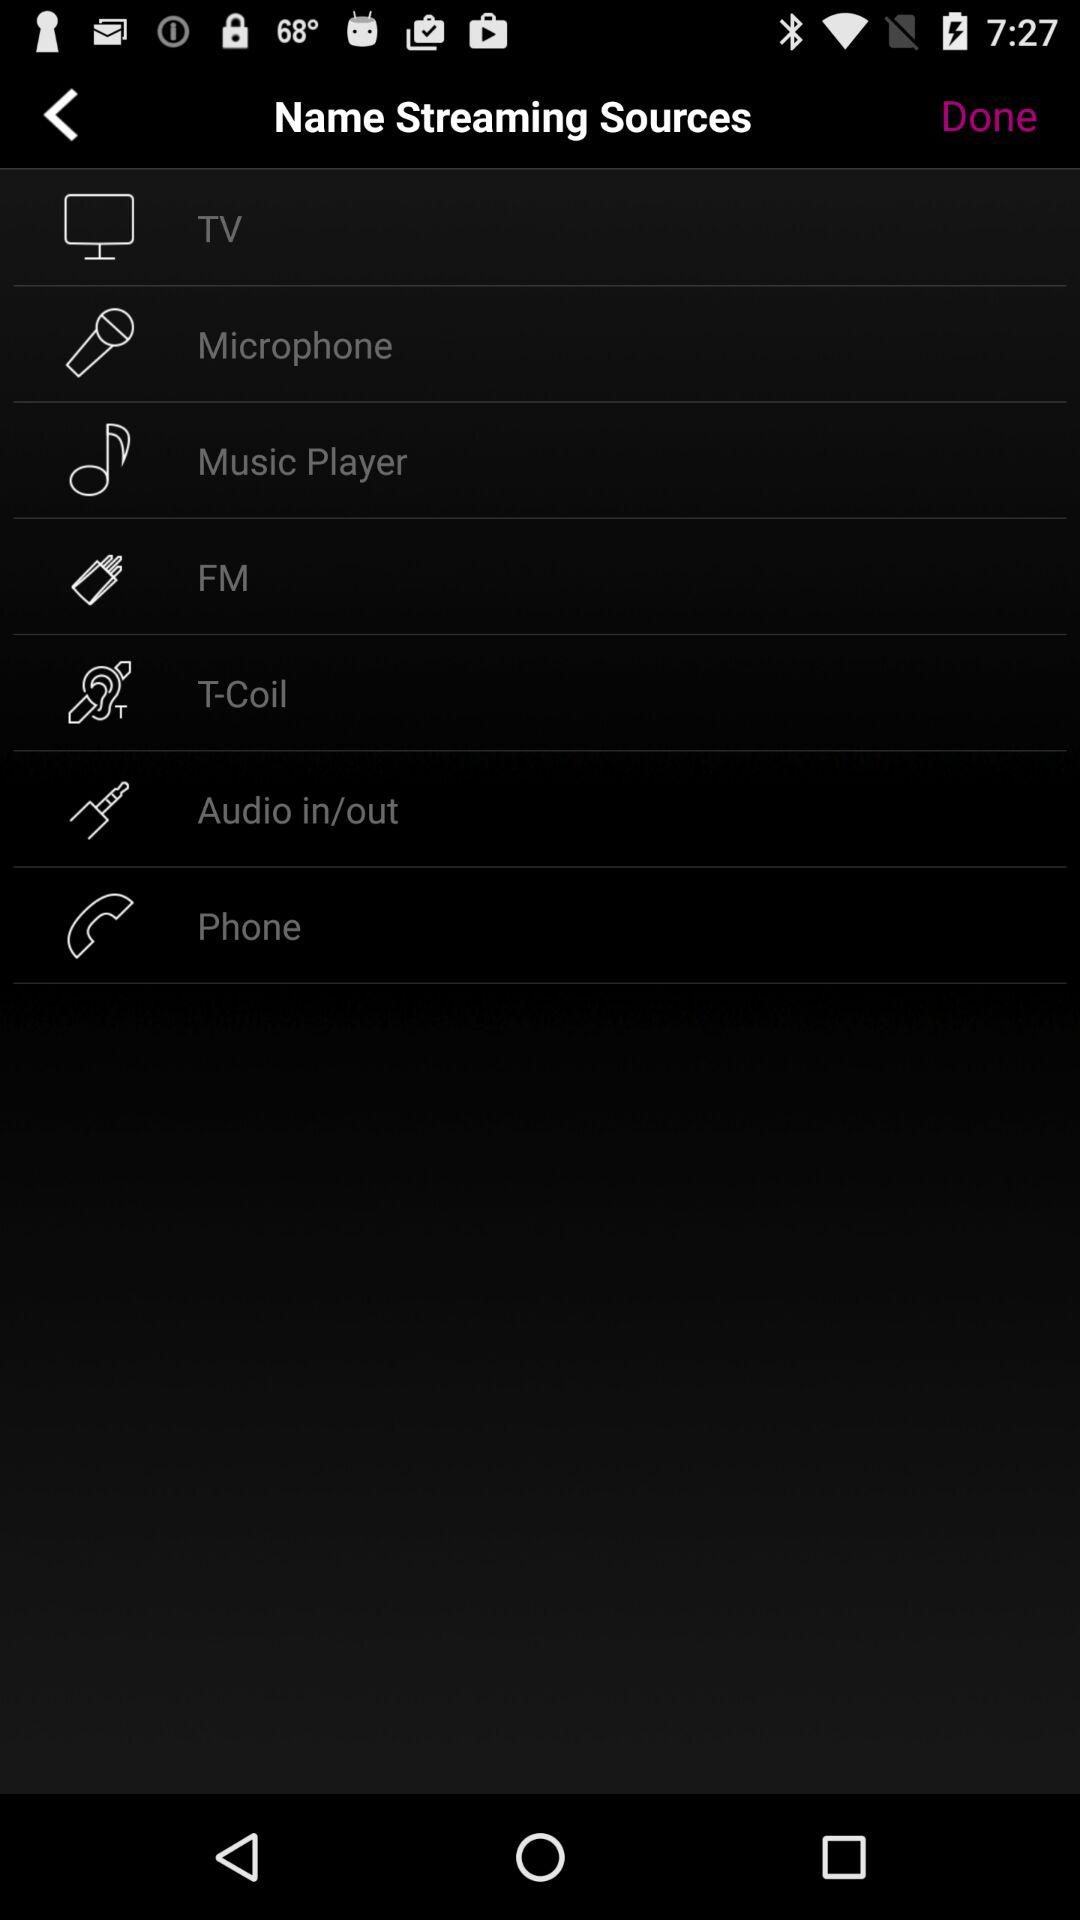How many streaming sources are there in total?
Answer the question using a single word or phrase. 7 